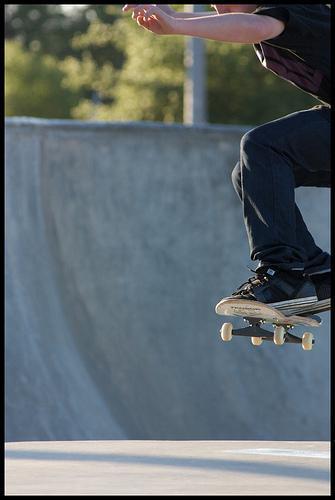How many people are shown?
Give a very brief answer. 1. 